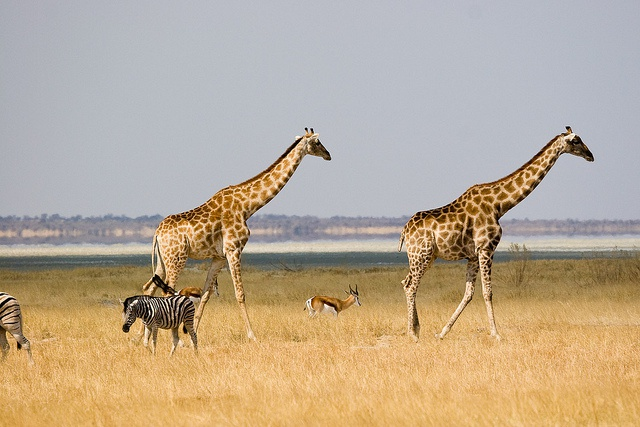Describe the objects in this image and their specific colors. I can see giraffe in darkgray, olive, tan, and maroon tones, giraffe in darkgray, olive, and tan tones, zebra in darkgray, black, maroon, and gray tones, and zebra in darkgray, gray, olive, black, and tan tones in this image. 